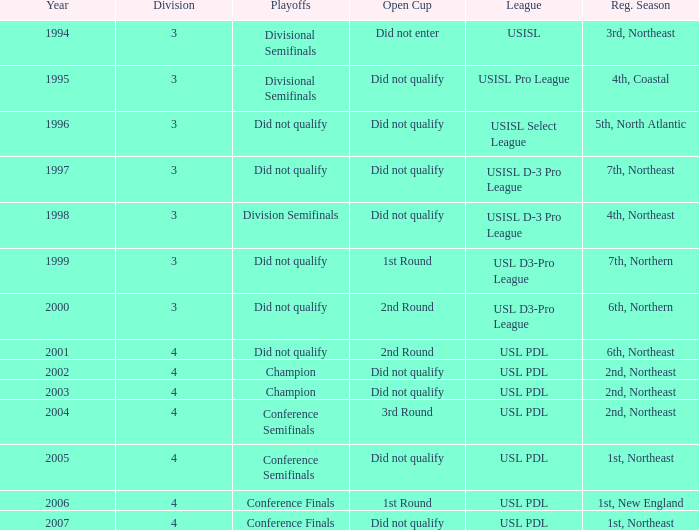Name the playoffs for  usisl select league Did not qualify. 